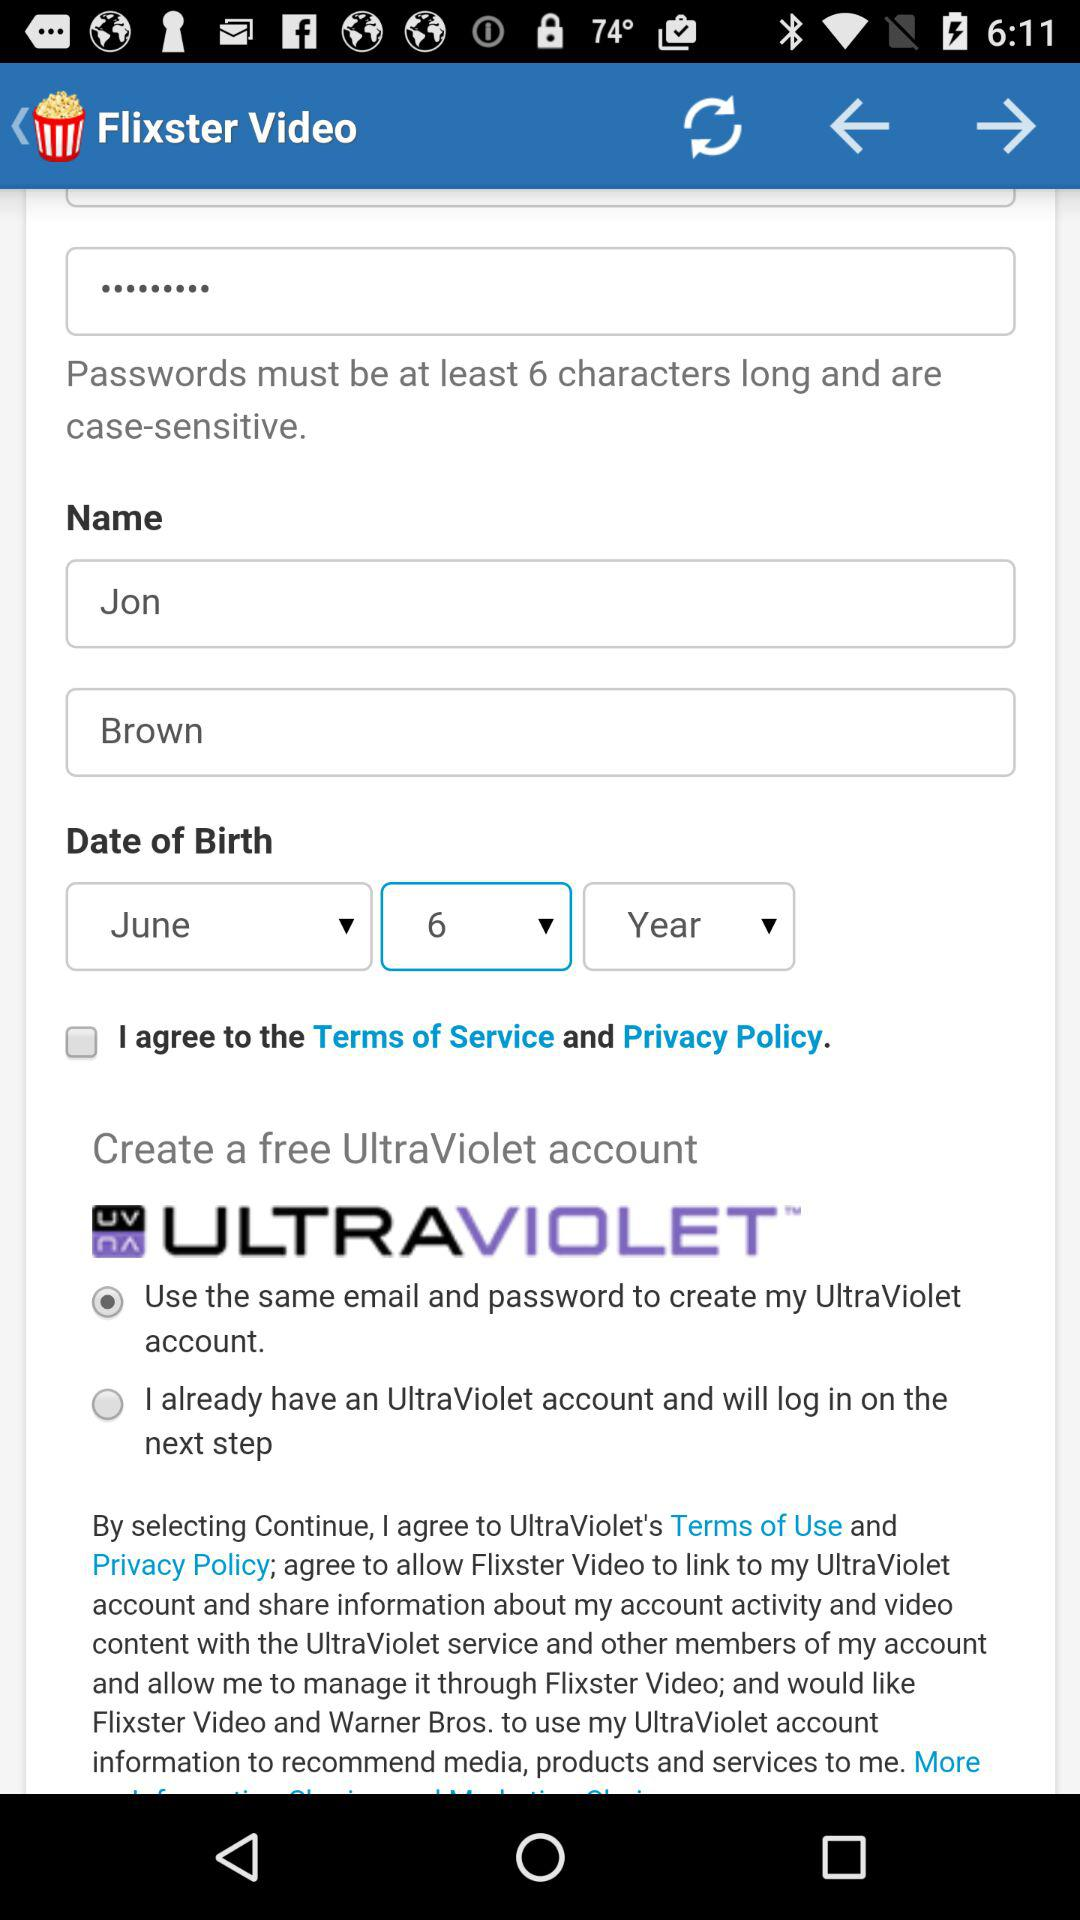What is the date of birth? The date of birth is June 6. 